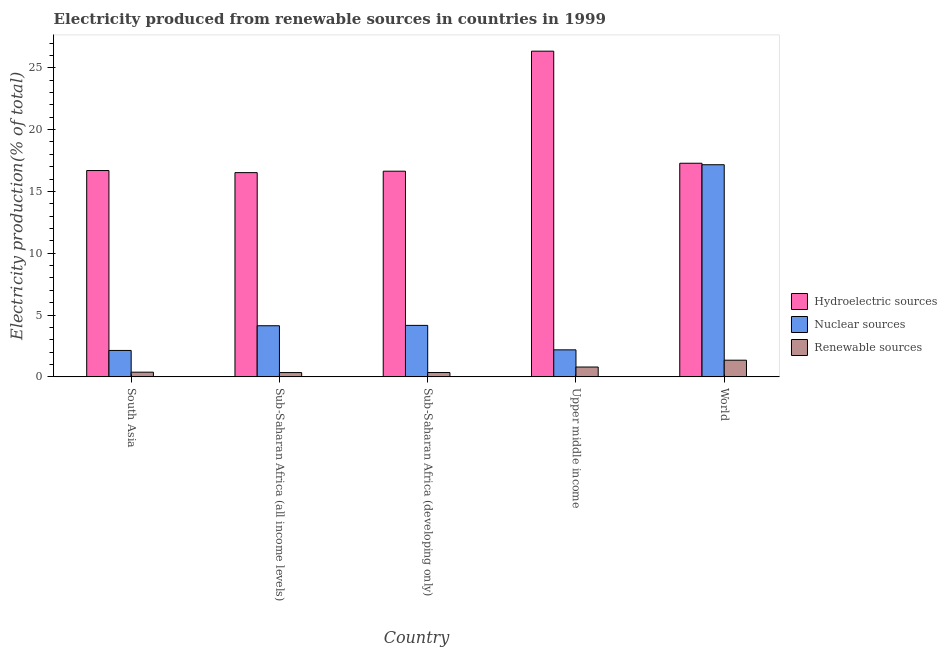How many different coloured bars are there?
Offer a terse response. 3. What is the label of the 4th group of bars from the left?
Give a very brief answer. Upper middle income. What is the percentage of electricity produced by hydroelectric sources in Sub-Saharan Africa (all income levels)?
Your answer should be very brief. 16.52. Across all countries, what is the maximum percentage of electricity produced by hydroelectric sources?
Ensure brevity in your answer.  26.34. Across all countries, what is the minimum percentage of electricity produced by renewable sources?
Your answer should be very brief. 0.35. In which country was the percentage of electricity produced by renewable sources minimum?
Your answer should be very brief. Sub-Saharan Africa (all income levels). What is the total percentage of electricity produced by hydroelectric sources in the graph?
Offer a terse response. 93.46. What is the difference between the percentage of electricity produced by renewable sources in Sub-Saharan Africa (all income levels) and that in Sub-Saharan Africa (developing only)?
Your response must be concise. -0. What is the difference between the percentage of electricity produced by hydroelectric sources in Sub-Saharan Africa (developing only) and the percentage of electricity produced by renewable sources in World?
Offer a very short reply. 15.29. What is the average percentage of electricity produced by nuclear sources per country?
Keep it short and to the point. 5.96. What is the difference between the percentage of electricity produced by nuclear sources and percentage of electricity produced by renewable sources in Sub-Saharan Africa (developing only)?
Keep it short and to the point. 3.81. In how many countries, is the percentage of electricity produced by hydroelectric sources greater than 5 %?
Offer a terse response. 5. What is the ratio of the percentage of electricity produced by renewable sources in Sub-Saharan Africa (all income levels) to that in World?
Offer a very short reply. 0.26. Is the percentage of electricity produced by hydroelectric sources in South Asia less than that in Sub-Saharan Africa (developing only)?
Provide a short and direct response. No. What is the difference between the highest and the second highest percentage of electricity produced by hydroelectric sources?
Give a very brief answer. 9.06. What is the difference between the highest and the lowest percentage of electricity produced by nuclear sources?
Keep it short and to the point. 15.02. In how many countries, is the percentage of electricity produced by renewable sources greater than the average percentage of electricity produced by renewable sources taken over all countries?
Give a very brief answer. 2. What does the 2nd bar from the left in Sub-Saharan Africa (all income levels) represents?
Your answer should be very brief. Nuclear sources. What does the 3rd bar from the right in Sub-Saharan Africa (developing only) represents?
Provide a succinct answer. Hydroelectric sources. How many bars are there?
Offer a terse response. 15. Are all the bars in the graph horizontal?
Offer a very short reply. No. What is the difference between two consecutive major ticks on the Y-axis?
Provide a succinct answer. 5. Are the values on the major ticks of Y-axis written in scientific E-notation?
Provide a succinct answer. No. Does the graph contain any zero values?
Offer a terse response. No. Where does the legend appear in the graph?
Ensure brevity in your answer.  Center right. How many legend labels are there?
Provide a succinct answer. 3. How are the legend labels stacked?
Provide a succinct answer. Vertical. What is the title of the graph?
Your answer should be very brief. Electricity produced from renewable sources in countries in 1999. What is the Electricity production(% of total) in Hydroelectric sources in South Asia?
Keep it short and to the point. 16.69. What is the Electricity production(% of total) in Nuclear sources in South Asia?
Offer a terse response. 2.14. What is the Electricity production(% of total) of Renewable sources in South Asia?
Make the answer very short. 0.38. What is the Electricity production(% of total) of Hydroelectric sources in Sub-Saharan Africa (all income levels)?
Provide a succinct answer. 16.52. What is the Electricity production(% of total) in Nuclear sources in Sub-Saharan Africa (all income levels)?
Keep it short and to the point. 4.14. What is the Electricity production(% of total) of Renewable sources in Sub-Saharan Africa (all income levels)?
Offer a very short reply. 0.35. What is the Electricity production(% of total) of Hydroelectric sources in Sub-Saharan Africa (developing only)?
Offer a terse response. 16.63. What is the Electricity production(% of total) of Nuclear sources in Sub-Saharan Africa (developing only)?
Provide a succinct answer. 4.16. What is the Electricity production(% of total) in Renewable sources in Sub-Saharan Africa (developing only)?
Your response must be concise. 0.35. What is the Electricity production(% of total) of Hydroelectric sources in Upper middle income?
Give a very brief answer. 26.34. What is the Electricity production(% of total) in Nuclear sources in Upper middle income?
Provide a succinct answer. 2.19. What is the Electricity production(% of total) of Renewable sources in Upper middle income?
Your response must be concise. 0.8. What is the Electricity production(% of total) in Hydroelectric sources in World?
Keep it short and to the point. 17.28. What is the Electricity production(% of total) in Nuclear sources in World?
Provide a short and direct response. 17.16. What is the Electricity production(% of total) in Renewable sources in World?
Give a very brief answer. 1.35. Across all countries, what is the maximum Electricity production(% of total) of Hydroelectric sources?
Your answer should be compact. 26.34. Across all countries, what is the maximum Electricity production(% of total) in Nuclear sources?
Ensure brevity in your answer.  17.16. Across all countries, what is the maximum Electricity production(% of total) in Renewable sources?
Offer a terse response. 1.35. Across all countries, what is the minimum Electricity production(% of total) of Hydroelectric sources?
Keep it short and to the point. 16.52. Across all countries, what is the minimum Electricity production(% of total) in Nuclear sources?
Your answer should be very brief. 2.14. Across all countries, what is the minimum Electricity production(% of total) of Renewable sources?
Your answer should be very brief. 0.35. What is the total Electricity production(% of total) in Hydroelectric sources in the graph?
Ensure brevity in your answer.  93.46. What is the total Electricity production(% of total) in Nuclear sources in the graph?
Provide a succinct answer. 29.78. What is the total Electricity production(% of total) in Renewable sources in the graph?
Provide a succinct answer. 3.22. What is the difference between the Electricity production(% of total) of Hydroelectric sources in South Asia and that in Sub-Saharan Africa (all income levels)?
Provide a short and direct response. 0.17. What is the difference between the Electricity production(% of total) in Nuclear sources in South Asia and that in Sub-Saharan Africa (all income levels)?
Provide a short and direct response. -2. What is the difference between the Electricity production(% of total) of Renewable sources in South Asia and that in Sub-Saharan Africa (all income levels)?
Provide a succinct answer. 0.03. What is the difference between the Electricity production(% of total) in Hydroelectric sources in South Asia and that in Sub-Saharan Africa (developing only)?
Your response must be concise. 0.05. What is the difference between the Electricity production(% of total) of Nuclear sources in South Asia and that in Sub-Saharan Africa (developing only)?
Make the answer very short. -2.03. What is the difference between the Electricity production(% of total) of Renewable sources in South Asia and that in Sub-Saharan Africa (developing only)?
Provide a succinct answer. 0.03. What is the difference between the Electricity production(% of total) in Hydroelectric sources in South Asia and that in Upper middle income?
Offer a terse response. -9.65. What is the difference between the Electricity production(% of total) in Nuclear sources in South Asia and that in Upper middle income?
Your answer should be very brief. -0.05. What is the difference between the Electricity production(% of total) of Renewable sources in South Asia and that in Upper middle income?
Your answer should be very brief. -0.42. What is the difference between the Electricity production(% of total) in Hydroelectric sources in South Asia and that in World?
Provide a short and direct response. -0.59. What is the difference between the Electricity production(% of total) of Nuclear sources in South Asia and that in World?
Offer a very short reply. -15.02. What is the difference between the Electricity production(% of total) of Renewable sources in South Asia and that in World?
Give a very brief answer. -0.97. What is the difference between the Electricity production(% of total) of Hydroelectric sources in Sub-Saharan Africa (all income levels) and that in Sub-Saharan Africa (developing only)?
Your answer should be very brief. -0.12. What is the difference between the Electricity production(% of total) of Nuclear sources in Sub-Saharan Africa (all income levels) and that in Sub-Saharan Africa (developing only)?
Provide a short and direct response. -0.03. What is the difference between the Electricity production(% of total) of Renewable sources in Sub-Saharan Africa (all income levels) and that in Sub-Saharan Africa (developing only)?
Your answer should be very brief. -0. What is the difference between the Electricity production(% of total) in Hydroelectric sources in Sub-Saharan Africa (all income levels) and that in Upper middle income?
Offer a terse response. -9.82. What is the difference between the Electricity production(% of total) in Nuclear sources in Sub-Saharan Africa (all income levels) and that in Upper middle income?
Offer a terse response. 1.95. What is the difference between the Electricity production(% of total) of Renewable sources in Sub-Saharan Africa (all income levels) and that in Upper middle income?
Offer a very short reply. -0.45. What is the difference between the Electricity production(% of total) of Hydroelectric sources in Sub-Saharan Africa (all income levels) and that in World?
Provide a short and direct response. -0.76. What is the difference between the Electricity production(% of total) in Nuclear sources in Sub-Saharan Africa (all income levels) and that in World?
Your answer should be very brief. -13.02. What is the difference between the Electricity production(% of total) in Renewable sources in Sub-Saharan Africa (all income levels) and that in World?
Provide a short and direct response. -1. What is the difference between the Electricity production(% of total) of Hydroelectric sources in Sub-Saharan Africa (developing only) and that in Upper middle income?
Offer a terse response. -9.71. What is the difference between the Electricity production(% of total) in Nuclear sources in Sub-Saharan Africa (developing only) and that in Upper middle income?
Provide a succinct answer. 1.98. What is the difference between the Electricity production(% of total) in Renewable sources in Sub-Saharan Africa (developing only) and that in Upper middle income?
Keep it short and to the point. -0.45. What is the difference between the Electricity production(% of total) of Hydroelectric sources in Sub-Saharan Africa (developing only) and that in World?
Your answer should be very brief. -0.64. What is the difference between the Electricity production(% of total) in Nuclear sources in Sub-Saharan Africa (developing only) and that in World?
Give a very brief answer. -12.99. What is the difference between the Electricity production(% of total) of Renewable sources in Sub-Saharan Africa (developing only) and that in World?
Your response must be concise. -1. What is the difference between the Electricity production(% of total) in Hydroelectric sources in Upper middle income and that in World?
Offer a terse response. 9.06. What is the difference between the Electricity production(% of total) of Nuclear sources in Upper middle income and that in World?
Give a very brief answer. -14.97. What is the difference between the Electricity production(% of total) of Renewable sources in Upper middle income and that in World?
Offer a very short reply. -0.55. What is the difference between the Electricity production(% of total) in Hydroelectric sources in South Asia and the Electricity production(% of total) in Nuclear sources in Sub-Saharan Africa (all income levels)?
Give a very brief answer. 12.55. What is the difference between the Electricity production(% of total) of Hydroelectric sources in South Asia and the Electricity production(% of total) of Renewable sources in Sub-Saharan Africa (all income levels)?
Make the answer very short. 16.34. What is the difference between the Electricity production(% of total) in Nuclear sources in South Asia and the Electricity production(% of total) in Renewable sources in Sub-Saharan Africa (all income levels)?
Offer a very short reply. 1.79. What is the difference between the Electricity production(% of total) of Hydroelectric sources in South Asia and the Electricity production(% of total) of Nuclear sources in Sub-Saharan Africa (developing only)?
Offer a very short reply. 12.52. What is the difference between the Electricity production(% of total) of Hydroelectric sources in South Asia and the Electricity production(% of total) of Renewable sources in Sub-Saharan Africa (developing only)?
Keep it short and to the point. 16.34. What is the difference between the Electricity production(% of total) in Nuclear sources in South Asia and the Electricity production(% of total) in Renewable sources in Sub-Saharan Africa (developing only)?
Offer a very short reply. 1.79. What is the difference between the Electricity production(% of total) of Hydroelectric sources in South Asia and the Electricity production(% of total) of Nuclear sources in Upper middle income?
Ensure brevity in your answer.  14.5. What is the difference between the Electricity production(% of total) of Hydroelectric sources in South Asia and the Electricity production(% of total) of Renewable sources in Upper middle income?
Give a very brief answer. 15.89. What is the difference between the Electricity production(% of total) of Nuclear sources in South Asia and the Electricity production(% of total) of Renewable sources in Upper middle income?
Your response must be concise. 1.34. What is the difference between the Electricity production(% of total) in Hydroelectric sources in South Asia and the Electricity production(% of total) in Nuclear sources in World?
Ensure brevity in your answer.  -0.47. What is the difference between the Electricity production(% of total) of Hydroelectric sources in South Asia and the Electricity production(% of total) of Renewable sources in World?
Make the answer very short. 15.34. What is the difference between the Electricity production(% of total) in Nuclear sources in South Asia and the Electricity production(% of total) in Renewable sources in World?
Your answer should be very brief. 0.79. What is the difference between the Electricity production(% of total) in Hydroelectric sources in Sub-Saharan Africa (all income levels) and the Electricity production(% of total) in Nuclear sources in Sub-Saharan Africa (developing only)?
Your answer should be compact. 12.35. What is the difference between the Electricity production(% of total) in Hydroelectric sources in Sub-Saharan Africa (all income levels) and the Electricity production(% of total) in Renewable sources in Sub-Saharan Africa (developing only)?
Your response must be concise. 16.17. What is the difference between the Electricity production(% of total) in Nuclear sources in Sub-Saharan Africa (all income levels) and the Electricity production(% of total) in Renewable sources in Sub-Saharan Africa (developing only)?
Offer a terse response. 3.79. What is the difference between the Electricity production(% of total) in Hydroelectric sources in Sub-Saharan Africa (all income levels) and the Electricity production(% of total) in Nuclear sources in Upper middle income?
Your response must be concise. 14.33. What is the difference between the Electricity production(% of total) of Hydroelectric sources in Sub-Saharan Africa (all income levels) and the Electricity production(% of total) of Renewable sources in Upper middle income?
Provide a succinct answer. 15.72. What is the difference between the Electricity production(% of total) in Nuclear sources in Sub-Saharan Africa (all income levels) and the Electricity production(% of total) in Renewable sources in Upper middle income?
Give a very brief answer. 3.34. What is the difference between the Electricity production(% of total) of Hydroelectric sources in Sub-Saharan Africa (all income levels) and the Electricity production(% of total) of Nuclear sources in World?
Provide a succinct answer. -0.64. What is the difference between the Electricity production(% of total) of Hydroelectric sources in Sub-Saharan Africa (all income levels) and the Electricity production(% of total) of Renewable sources in World?
Offer a very short reply. 15.17. What is the difference between the Electricity production(% of total) in Nuclear sources in Sub-Saharan Africa (all income levels) and the Electricity production(% of total) in Renewable sources in World?
Ensure brevity in your answer.  2.79. What is the difference between the Electricity production(% of total) in Hydroelectric sources in Sub-Saharan Africa (developing only) and the Electricity production(% of total) in Nuclear sources in Upper middle income?
Give a very brief answer. 14.45. What is the difference between the Electricity production(% of total) in Hydroelectric sources in Sub-Saharan Africa (developing only) and the Electricity production(% of total) in Renewable sources in Upper middle income?
Your answer should be very brief. 15.84. What is the difference between the Electricity production(% of total) of Nuclear sources in Sub-Saharan Africa (developing only) and the Electricity production(% of total) of Renewable sources in Upper middle income?
Give a very brief answer. 3.37. What is the difference between the Electricity production(% of total) in Hydroelectric sources in Sub-Saharan Africa (developing only) and the Electricity production(% of total) in Nuclear sources in World?
Your response must be concise. -0.52. What is the difference between the Electricity production(% of total) of Hydroelectric sources in Sub-Saharan Africa (developing only) and the Electricity production(% of total) of Renewable sources in World?
Provide a succinct answer. 15.29. What is the difference between the Electricity production(% of total) of Nuclear sources in Sub-Saharan Africa (developing only) and the Electricity production(% of total) of Renewable sources in World?
Ensure brevity in your answer.  2.82. What is the difference between the Electricity production(% of total) of Hydroelectric sources in Upper middle income and the Electricity production(% of total) of Nuclear sources in World?
Ensure brevity in your answer.  9.19. What is the difference between the Electricity production(% of total) in Hydroelectric sources in Upper middle income and the Electricity production(% of total) in Renewable sources in World?
Offer a terse response. 24.99. What is the difference between the Electricity production(% of total) of Nuclear sources in Upper middle income and the Electricity production(% of total) of Renewable sources in World?
Offer a very short reply. 0.84. What is the average Electricity production(% of total) in Hydroelectric sources per country?
Your response must be concise. 18.69. What is the average Electricity production(% of total) of Nuclear sources per country?
Provide a succinct answer. 5.96. What is the average Electricity production(% of total) in Renewable sources per country?
Your response must be concise. 0.64. What is the difference between the Electricity production(% of total) of Hydroelectric sources and Electricity production(% of total) of Nuclear sources in South Asia?
Ensure brevity in your answer.  14.55. What is the difference between the Electricity production(% of total) of Hydroelectric sources and Electricity production(% of total) of Renewable sources in South Asia?
Provide a short and direct response. 16.31. What is the difference between the Electricity production(% of total) of Nuclear sources and Electricity production(% of total) of Renewable sources in South Asia?
Your answer should be compact. 1.76. What is the difference between the Electricity production(% of total) of Hydroelectric sources and Electricity production(% of total) of Nuclear sources in Sub-Saharan Africa (all income levels)?
Your answer should be very brief. 12.38. What is the difference between the Electricity production(% of total) in Hydroelectric sources and Electricity production(% of total) in Renewable sources in Sub-Saharan Africa (all income levels)?
Offer a terse response. 16.17. What is the difference between the Electricity production(% of total) of Nuclear sources and Electricity production(% of total) of Renewable sources in Sub-Saharan Africa (all income levels)?
Give a very brief answer. 3.79. What is the difference between the Electricity production(% of total) of Hydroelectric sources and Electricity production(% of total) of Nuclear sources in Sub-Saharan Africa (developing only)?
Offer a very short reply. 12.47. What is the difference between the Electricity production(% of total) in Hydroelectric sources and Electricity production(% of total) in Renewable sources in Sub-Saharan Africa (developing only)?
Keep it short and to the point. 16.28. What is the difference between the Electricity production(% of total) in Nuclear sources and Electricity production(% of total) in Renewable sources in Sub-Saharan Africa (developing only)?
Your answer should be very brief. 3.81. What is the difference between the Electricity production(% of total) in Hydroelectric sources and Electricity production(% of total) in Nuclear sources in Upper middle income?
Your answer should be very brief. 24.16. What is the difference between the Electricity production(% of total) of Hydroelectric sources and Electricity production(% of total) of Renewable sources in Upper middle income?
Provide a short and direct response. 25.55. What is the difference between the Electricity production(% of total) of Nuclear sources and Electricity production(% of total) of Renewable sources in Upper middle income?
Your answer should be very brief. 1.39. What is the difference between the Electricity production(% of total) of Hydroelectric sources and Electricity production(% of total) of Nuclear sources in World?
Make the answer very short. 0.12. What is the difference between the Electricity production(% of total) in Hydroelectric sources and Electricity production(% of total) in Renewable sources in World?
Offer a very short reply. 15.93. What is the difference between the Electricity production(% of total) in Nuclear sources and Electricity production(% of total) in Renewable sources in World?
Your answer should be very brief. 15.81. What is the ratio of the Electricity production(% of total) in Hydroelectric sources in South Asia to that in Sub-Saharan Africa (all income levels)?
Give a very brief answer. 1.01. What is the ratio of the Electricity production(% of total) of Nuclear sources in South Asia to that in Sub-Saharan Africa (all income levels)?
Provide a short and direct response. 0.52. What is the ratio of the Electricity production(% of total) in Renewable sources in South Asia to that in Sub-Saharan Africa (all income levels)?
Ensure brevity in your answer.  1.09. What is the ratio of the Electricity production(% of total) of Hydroelectric sources in South Asia to that in Sub-Saharan Africa (developing only)?
Provide a short and direct response. 1. What is the ratio of the Electricity production(% of total) in Nuclear sources in South Asia to that in Sub-Saharan Africa (developing only)?
Offer a terse response. 0.51. What is the ratio of the Electricity production(% of total) in Renewable sources in South Asia to that in Sub-Saharan Africa (developing only)?
Your answer should be very brief. 1.08. What is the ratio of the Electricity production(% of total) in Hydroelectric sources in South Asia to that in Upper middle income?
Your answer should be very brief. 0.63. What is the ratio of the Electricity production(% of total) of Nuclear sources in South Asia to that in Upper middle income?
Keep it short and to the point. 0.98. What is the ratio of the Electricity production(% of total) in Renewable sources in South Asia to that in Upper middle income?
Your answer should be very brief. 0.48. What is the ratio of the Electricity production(% of total) in Hydroelectric sources in South Asia to that in World?
Offer a terse response. 0.97. What is the ratio of the Electricity production(% of total) in Nuclear sources in South Asia to that in World?
Provide a succinct answer. 0.12. What is the ratio of the Electricity production(% of total) of Renewable sources in South Asia to that in World?
Give a very brief answer. 0.28. What is the ratio of the Electricity production(% of total) in Nuclear sources in Sub-Saharan Africa (all income levels) to that in Sub-Saharan Africa (developing only)?
Provide a succinct answer. 0.99. What is the ratio of the Electricity production(% of total) in Hydroelectric sources in Sub-Saharan Africa (all income levels) to that in Upper middle income?
Ensure brevity in your answer.  0.63. What is the ratio of the Electricity production(% of total) of Nuclear sources in Sub-Saharan Africa (all income levels) to that in Upper middle income?
Give a very brief answer. 1.89. What is the ratio of the Electricity production(% of total) in Renewable sources in Sub-Saharan Africa (all income levels) to that in Upper middle income?
Give a very brief answer. 0.44. What is the ratio of the Electricity production(% of total) of Hydroelectric sources in Sub-Saharan Africa (all income levels) to that in World?
Give a very brief answer. 0.96. What is the ratio of the Electricity production(% of total) of Nuclear sources in Sub-Saharan Africa (all income levels) to that in World?
Offer a very short reply. 0.24. What is the ratio of the Electricity production(% of total) in Renewable sources in Sub-Saharan Africa (all income levels) to that in World?
Give a very brief answer. 0.26. What is the ratio of the Electricity production(% of total) in Hydroelectric sources in Sub-Saharan Africa (developing only) to that in Upper middle income?
Ensure brevity in your answer.  0.63. What is the ratio of the Electricity production(% of total) of Nuclear sources in Sub-Saharan Africa (developing only) to that in Upper middle income?
Ensure brevity in your answer.  1.91. What is the ratio of the Electricity production(% of total) of Renewable sources in Sub-Saharan Africa (developing only) to that in Upper middle income?
Provide a succinct answer. 0.44. What is the ratio of the Electricity production(% of total) in Hydroelectric sources in Sub-Saharan Africa (developing only) to that in World?
Keep it short and to the point. 0.96. What is the ratio of the Electricity production(% of total) in Nuclear sources in Sub-Saharan Africa (developing only) to that in World?
Ensure brevity in your answer.  0.24. What is the ratio of the Electricity production(% of total) in Renewable sources in Sub-Saharan Africa (developing only) to that in World?
Give a very brief answer. 0.26. What is the ratio of the Electricity production(% of total) of Hydroelectric sources in Upper middle income to that in World?
Provide a succinct answer. 1.52. What is the ratio of the Electricity production(% of total) of Nuclear sources in Upper middle income to that in World?
Offer a terse response. 0.13. What is the ratio of the Electricity production(% of total) in Renewable sources in Upper middle income to that in World?
Your answer should be very brief. 0.59. What is the difference between the highest and the second highest Electricity production(% of total) of Hydroelectric sources?
Your response must be concise. 9.06. What is the difference between the highest and the second highest Electricity production(% of total) of Nuclear sources?
Give a very brief answer. 12.99. What is the difference between the highest and the second highest Electricity production(% of total) in Renewable sources?
Give a very brief answer. 0.55. What is the difference between the highest and the lowest Electricity production(% of total) of Hydroelectric sources?
Give a very brief answer. 9.82. What is the difference between the highest and the lowest Electricity production(% of total) in Nuclear sources?
Ensure brevity in your answer.  15.02. What is the difference between the highest and the lowest Electricity production(% of total) in Renewable sources?
Your answer should be very brief. 1. 